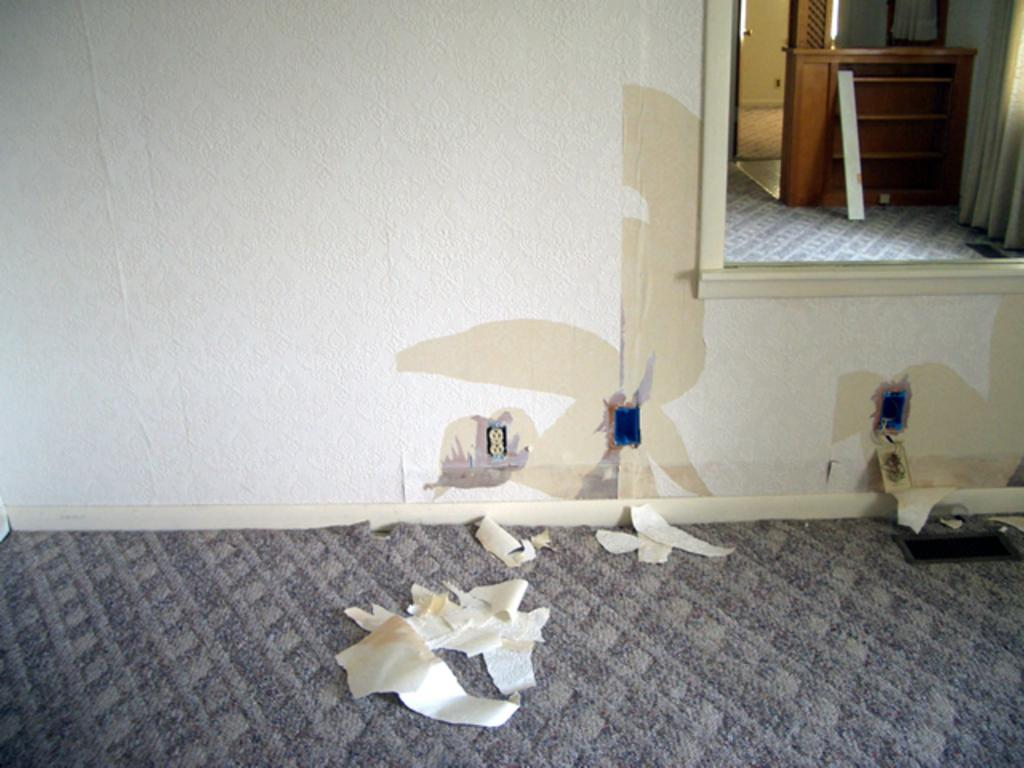What object is hanging on the wall in the image? There is a mirror on the wall in the image. What type of surface is the papers placed on in the image? The papers are placed on the carpet in the image. What type of farmer is depicted in the history book on the carpet in the image? There is no farmer or history book present in the image; it only features a mirror on the wall and papers on the carpet. What type of arch can be seen supporting the ceiling in the image? There is no arch present in the image; it only features a mirror on the wall and papers on the carpet. 